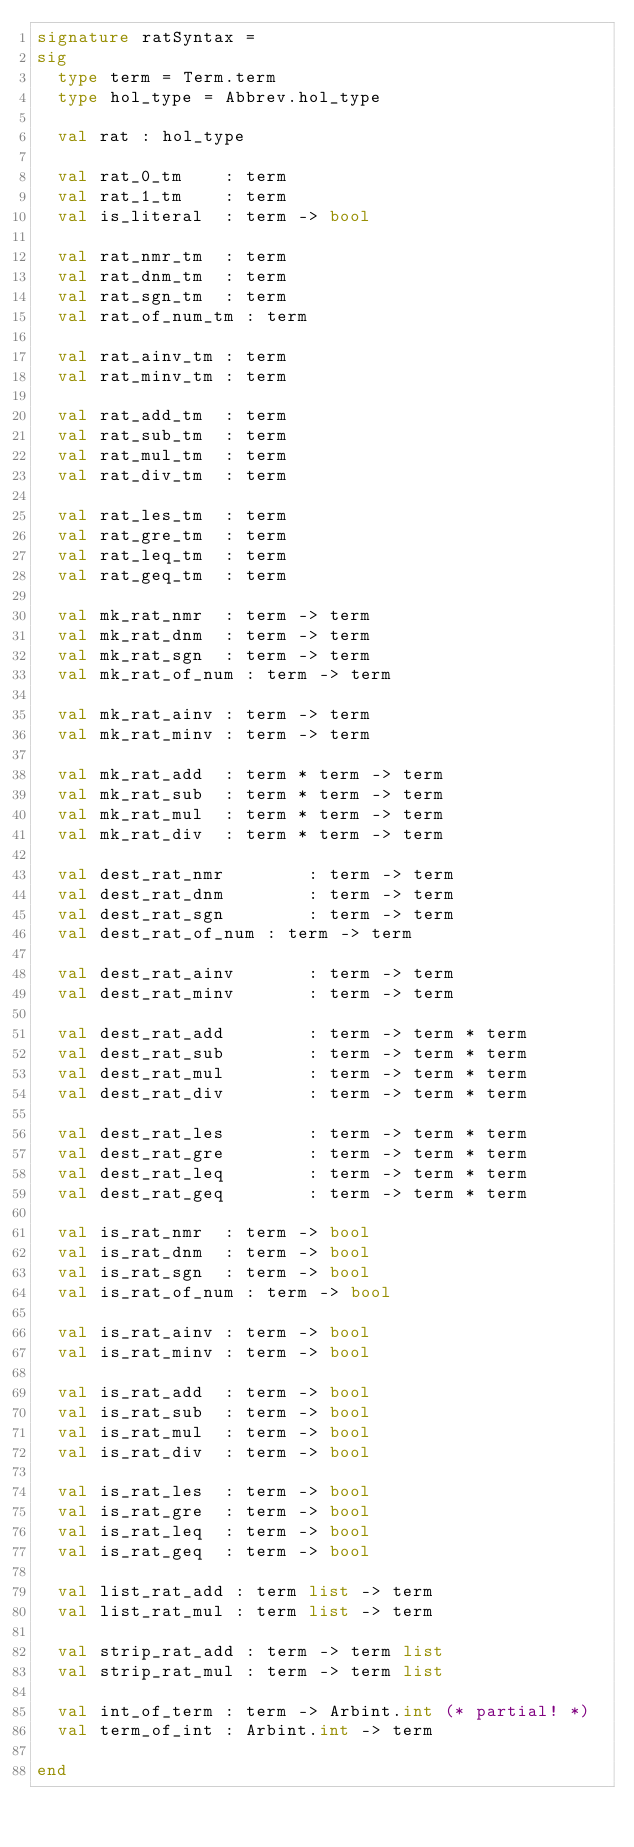Convert code to text. <code><loc_0><loc_0><loc_500><loc_500><_SML_>signature ratSyntax =
sig
  type term = Term.term
  type hol_type = Abbrev.hol_type

  val rat : hol_type

  val rat_0_tm    : term
  val rat_1_tm    : term
  val is_literal  : term -> bool

  val rat_nmr_tm  : term
  val rat_dnm_tm  : term
  val rat_sgn_tm  : term
  val rat_of_num_tm : term

  val rat_ainv_tm : term
  val rat_minv_tm : term

  val rat_add_tm  : term
  val rat_sub_tm  : term
  val rat_mul_tm  : term
  val rat_div_tm  : term

  val rat_les_tm  : term
  val rat_gre_tm  : term
  val rat_leq_tm  : term
  val rat_geq_tm  : term

  val mk_rat_nmr  : term -> term
  val mk_rat_dnm  : term -> term
  val mk_rat_sgn  : term -> term
  val mk_rat_of_num : term -> term

  val mk_rat_ainv : term -> term
  val mk_rat_minv : term -> term

  val mk_rat_add  : term * term -> term
  val mk_rat_sub  : term * term -> term
  val mk_rat_mul  : term * term -> term
  val mk_rat_div  : term * term -> term

  val dest_rat_nmr        : term -> term
  val dest_rat_dnm        : term -> term
  val dest_rat_sgn        : term -> term
  val dest_rat_of_num : term -> term

  val dest_rat_ainv       : term -> term
  val dest_rat_minv       : term -> term

  val dest_rat_add        : term -> term * term
  val dest_rat_sub        : term -> term * term
  val dest_rat_mul        : term -> term * term
  val dest_rat_div        : term -> term * term

  val dest_rat_les        : term -> term * term
  val dest_rat_gre        : term -> term * term
  val dest_rat_leq        : term -> term * term
  val dest_rat_geq        : term -> term * term

  val is_rat_nmr  : term -> bool
  val is_rat_dnm  : term -> bool
  val is_rat_sgn  : term -> bool
  val is_rat_of_num : term -> bool

  val is_rat_ainv : term -> bool
  val is_rat_minv : term -> bool

  val is_rat_add  : term -> bool
  val is_rat_sub  : term -> bool
  val is_rat_mul  : term -> bool
  val is_rat_div  : term -> bool

  val is_rat_les  : term -> bool
  val is_rat_gre  : term -> bool
  val is_rat_leq  : term -> bool
  val is_rat_geq  : term -> bool

  val list_rat_add : term list -> term
  val list_rat_mul : term list -> term

  val strip_rat_add : term -> term list
  val strip_rat_mul : term -> term list

  val int_of_term : term -> Arbint.int (* partial! *)
  val term_of_int : Arbint.int -> term

end
</code> 